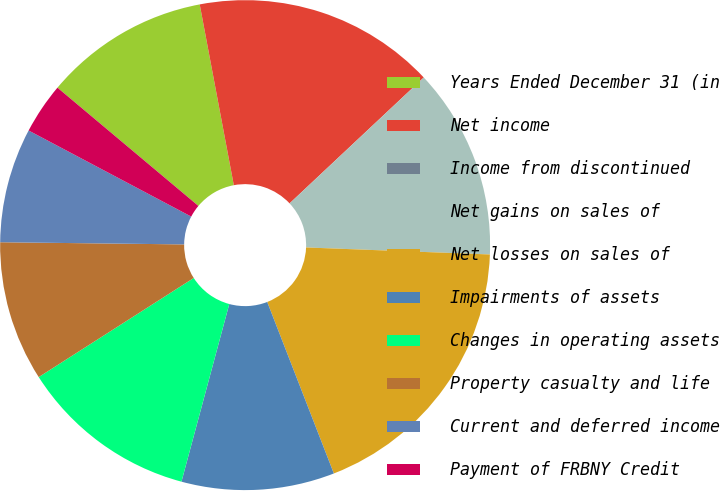Convert chart to OTSL. <chart><loc_0><loc_0><loc_500><loc_500><pie_chart><fcel>Years Ended December 31 (in<fcel>Net income<fcel>Income from discontinued<fcel>Net gains on sales of<fcel>Net losses on sales of<fcel>Impairments of assets<fcel>Changes in operating assets<fcel>Property casualty and life<fcel>Current and deferred income<fcel>Payment of FRBNY Credit<nl><fcel>10.92%<fcel>15.97%<fcel>0.0%<fcel>12.6%<fcel>18.49%<fcel>10.08%<fcel>11.76%<fcel>9.24%<fcel>7.56%<fcel>3.36%<nl></chart> 